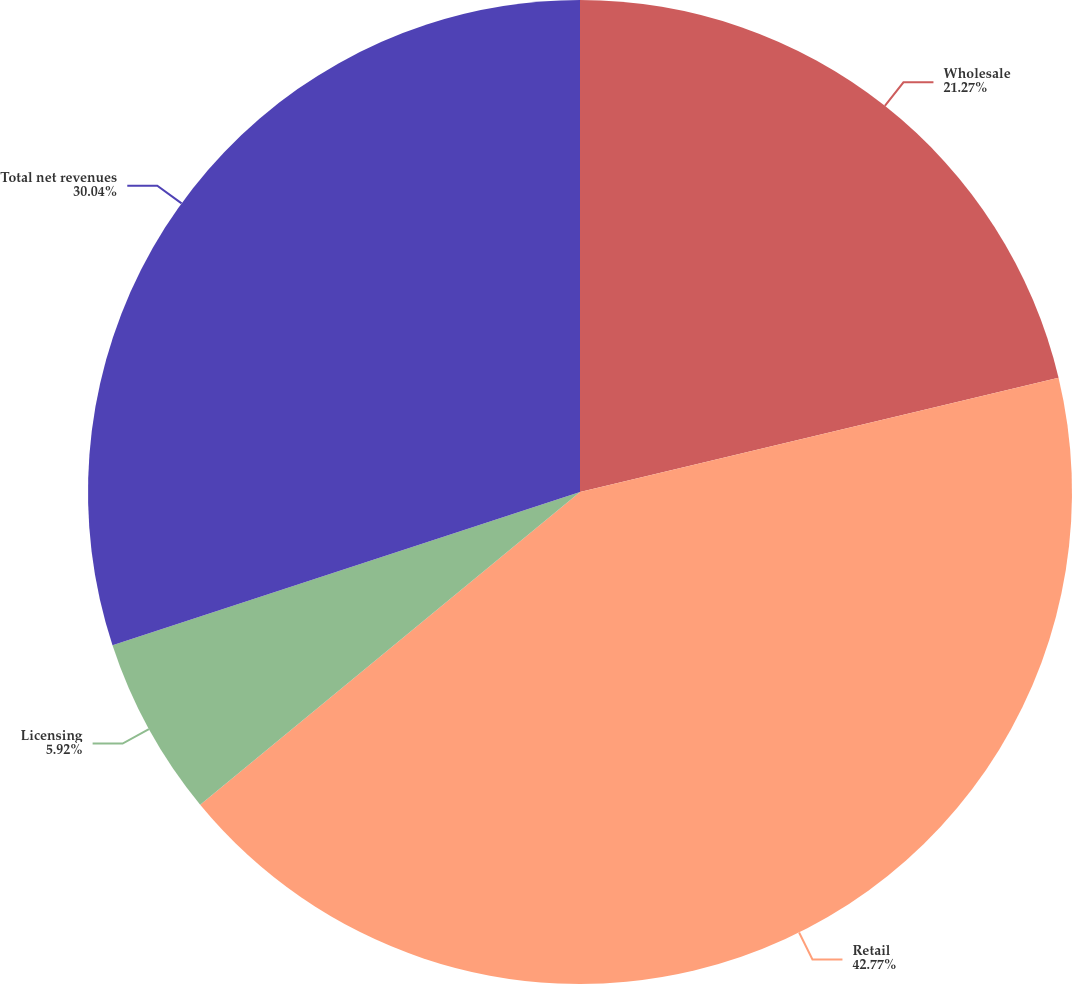Convert chart to OTSL. <chart><loc_0><loc_0><loc_500><loc_500><pie_chart><fcel>Wholesale<fcel>Retail<fcel>Licensing<fcel>Total net revenues<nl><fcel>21.27%<fcel>42.76%<fcel>5.92%<fcel>30.04%<nl></chart> 